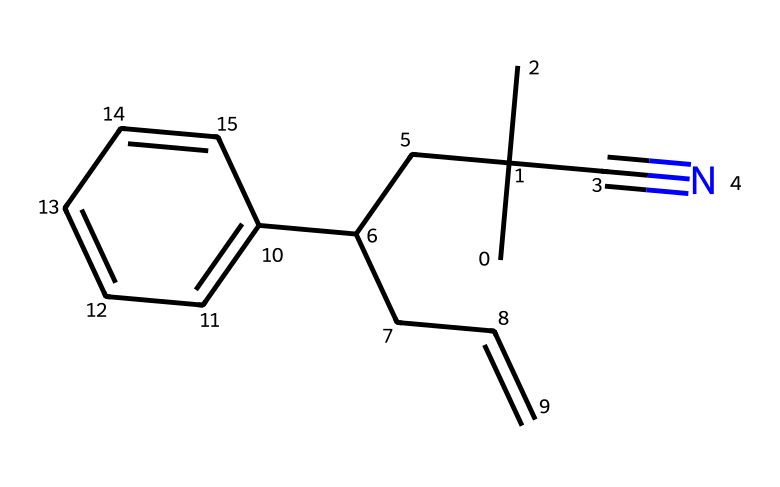What is the main functional group in acrylonitrile butadiene styrene? The main functional group is the cyano group (–C≡N), which is derived from the acrylonitrile component of the polymer.
Answer: cyano group How many carbon atoms are in this molecule? By counting all the carbon atoms present in the SMILES representation, there are a total of 15 carbon atoms, including those in the rings and branching structures.
Answer: 15 What type of polymer is acrylonitrile butadiene styrene? ABS is a thermoplastic, which means it can be melted and reshaped upon heating due to the nature of its covalent bonding and molecular structure.
Answer: thermoplastic Which component contributes to the rubbery properties of ABS? The butadiene component provides the rubbery characteristics due to its saturated chain structure, giving flexibility and toughness to the overall polymer.
Answer: butadiene What is the primary use of acrylonitrile butadiene styrene? ABS is commonly used in the production of consumer products, such as toys, automotive parts, and household items, due to its durability and impact resistance.
Answer: consumer products How many hydrogen atoms are present in the molecule? By evaluating the structure and counting the hydrogen atoms attached to each carbon and nitrogen, there are 16 hydrogen atoms present in this chemical's structure.
Answer: 16 What effect does the presence of the cyano group have on ABS properties? The cyano group introduces polarity in the polymer, which affects its thermal stability and chemical resistance, making it suitable for various applications.
Answer: polarity 